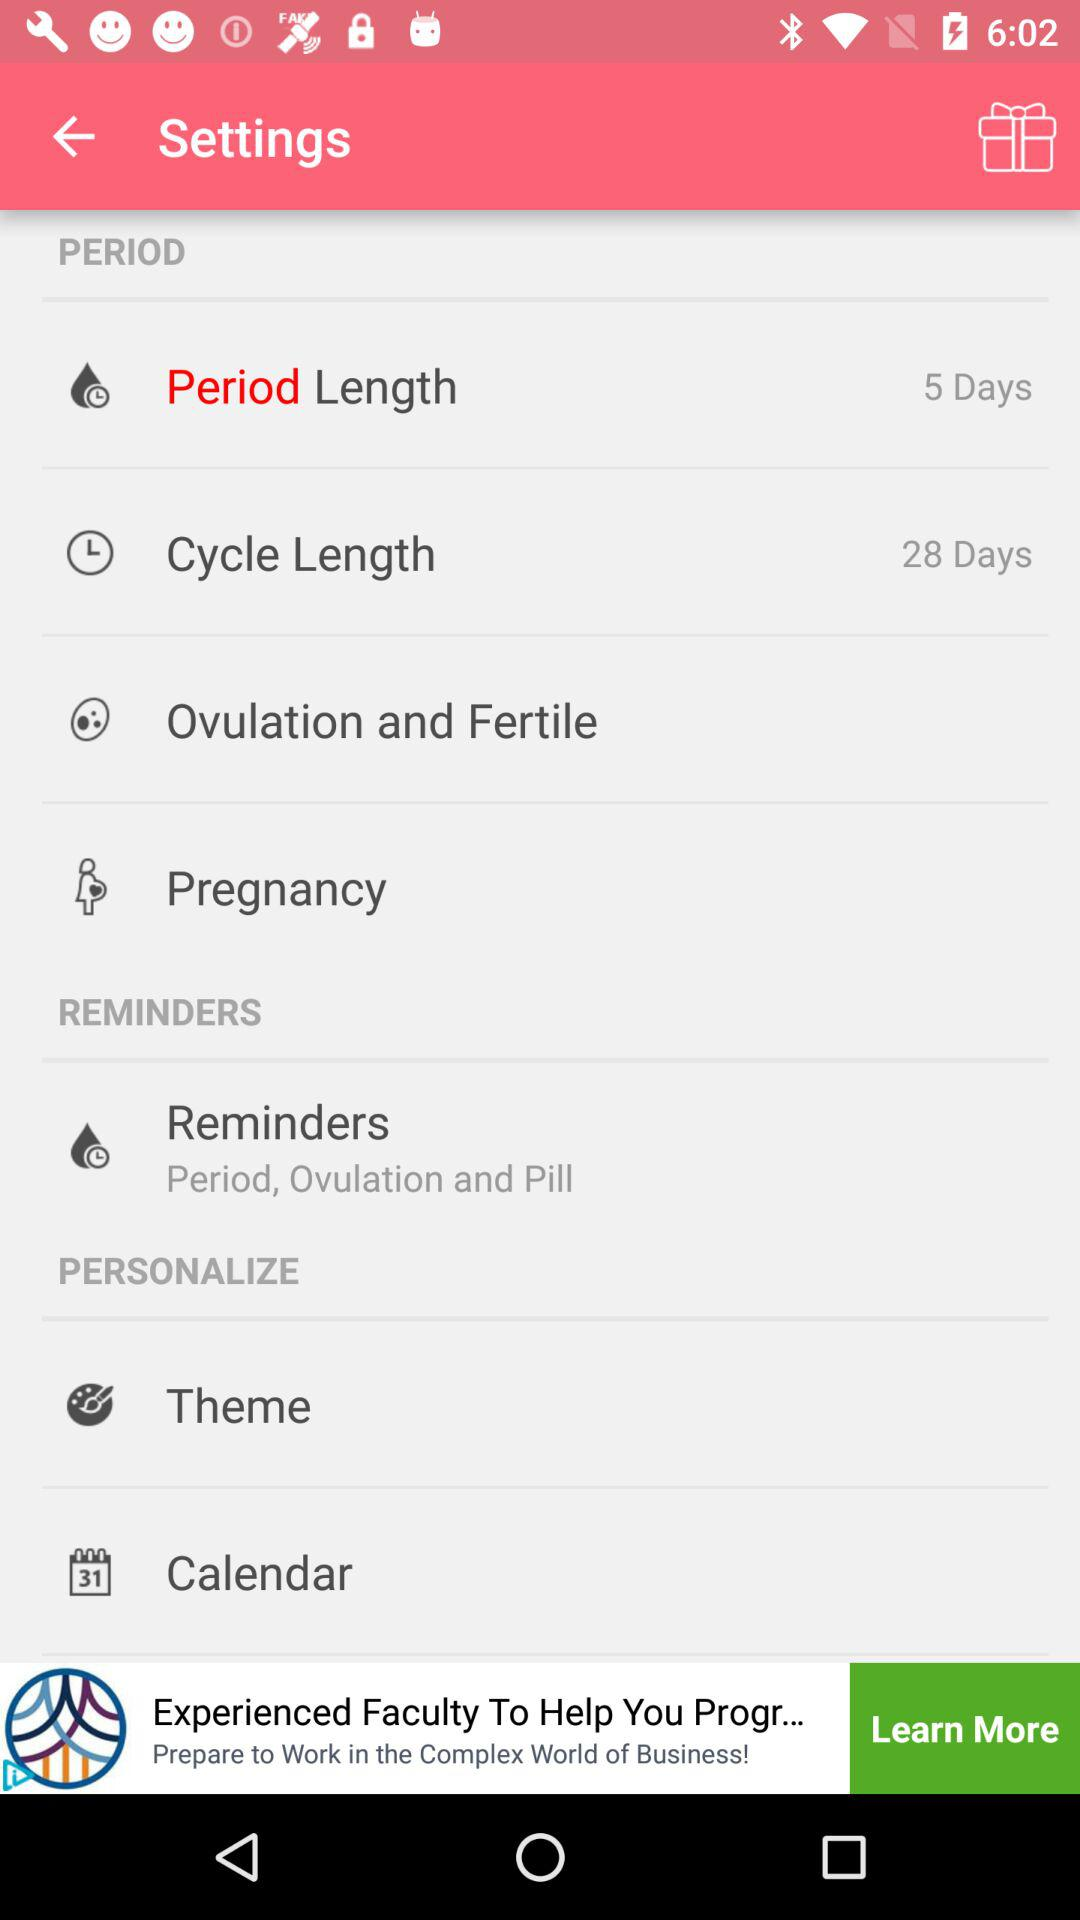How much is the period length? The period length is 5 days. 